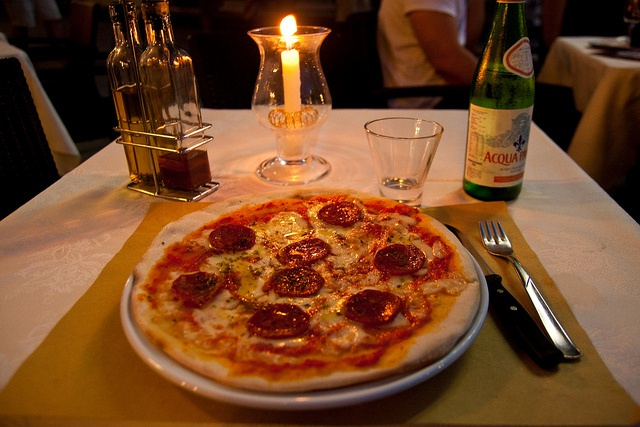Describe the objects in this image and their specific colors. I can see dining table in black, tan, gray, maroon, and brown tones, pizza in black, red, and maroon tones, bottle in black, olive, and maroon tones, people in black, maroon, and brown tones, and bottle in black, maroon, gray, and brown tones in this image. 